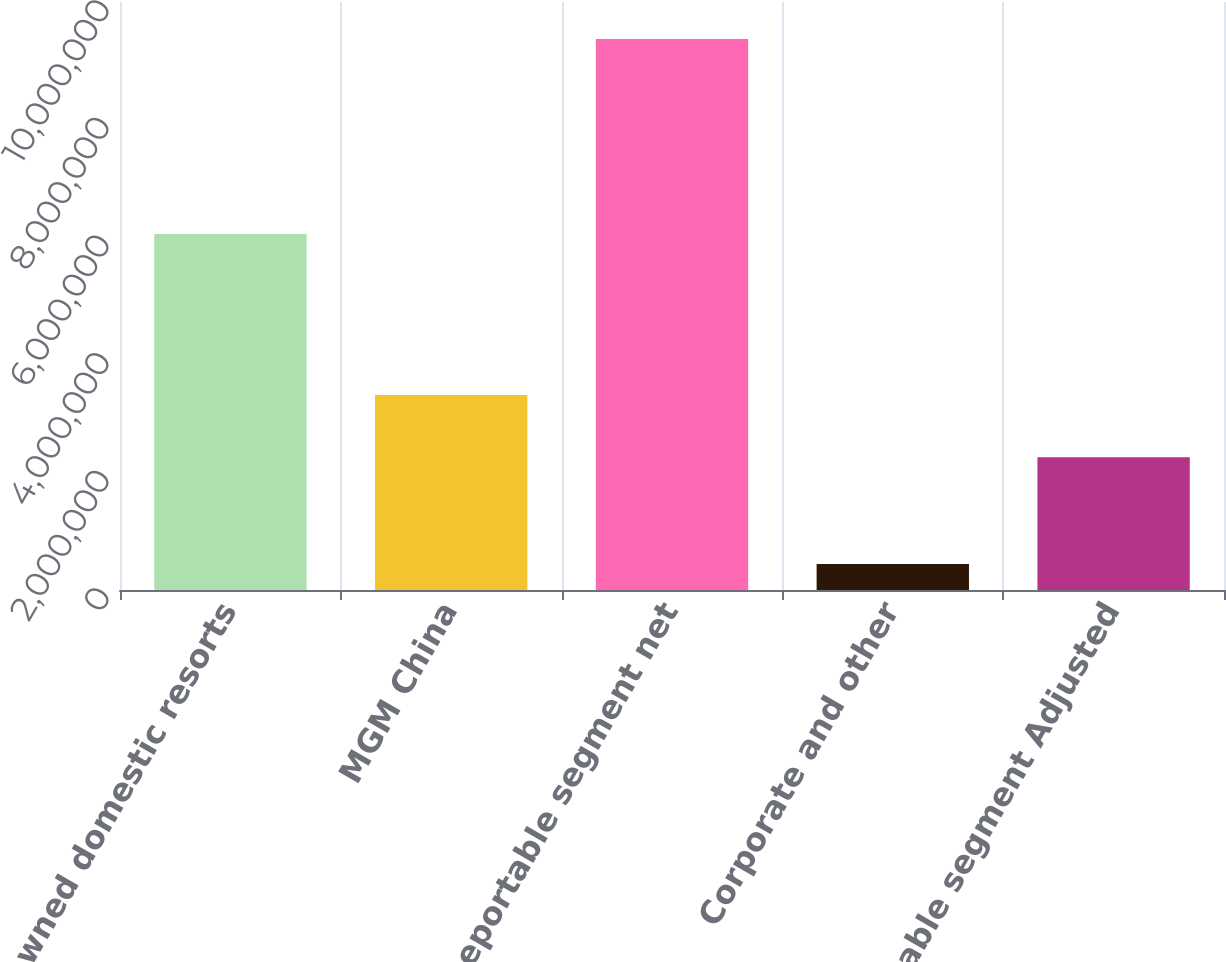Convert chart. <chart><loc_0><loc_0><loc_500><loc_500><bar_chart><fcel>Wholly owned domestic resorts<fcel>MGM China<fcel>Reportable segment net<fcel>Corporate and other<fcel>Reportable segment Adjusted<nl><fcel>6.05264e+06<fcel>3.31693e+06<fcel>9.36957e+06<fcel>440091<fcel>2.2568e+06<nl></chart> 